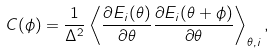Convert formula to latex. <formula><loc_0><loc_0><loc_500><loc_500>C ( \phi ) = \frac { 1 } { \Delta ^ { 2 } } \left \langle \frac { \partial E _ { i } ( \theta ) } { \partial \theta } \frac { \partial E _ { i } ( \theta + \phi ) } { \partial \theta } \right \rangle _ { \theta , i } ,</formula> 